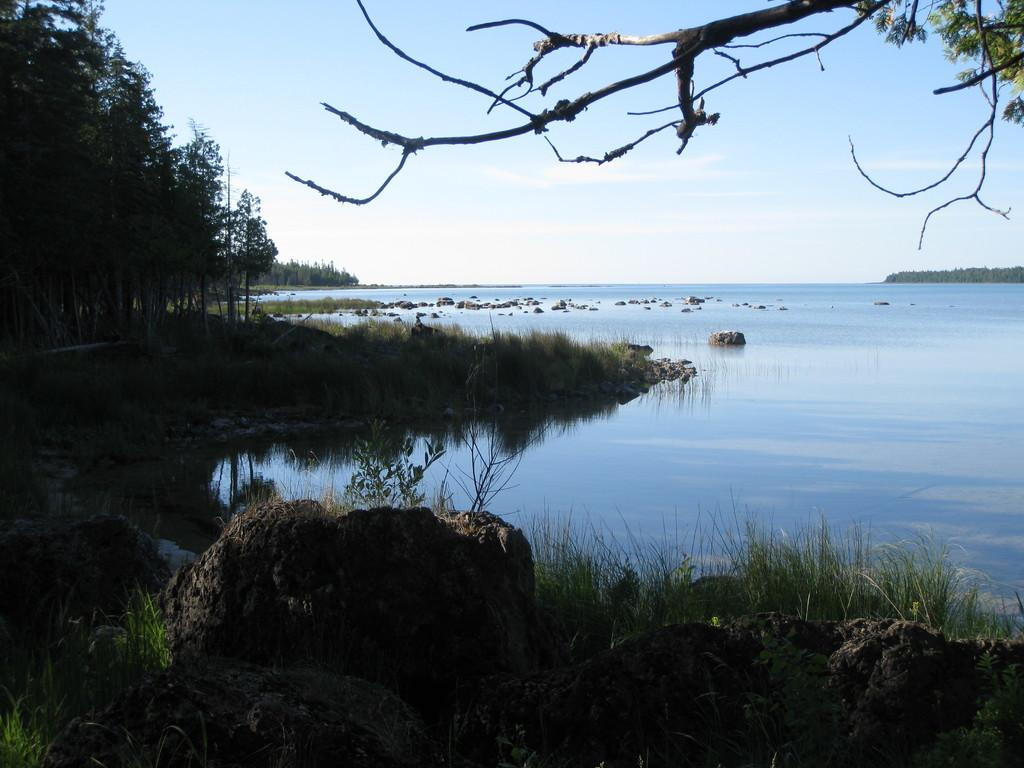What type of vegetation can be seen in the image? There are trees in the image. What else can be seen on the ground in the image? There is grass in the image. What is the water feature in the image? The water is visible in the image. What can be seen in the background of the image? The sky is visible in the background of the image. Where is the mask located in the image? There is no mask present in the image. What type of store can be seen in the image? There is no store present in the image. 